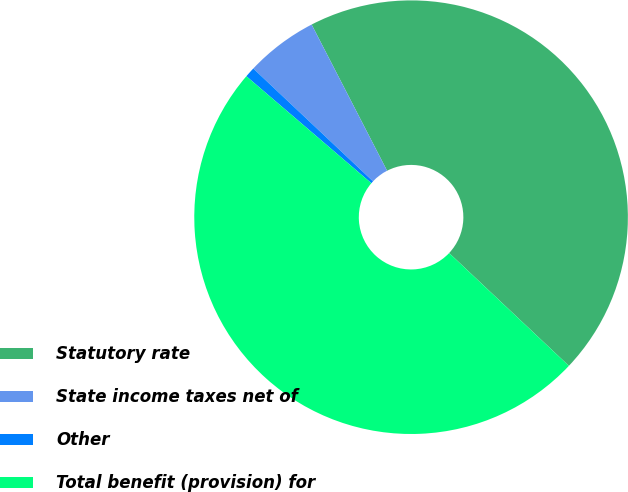<chart> <loc_0><loc_0><loc_500><loc_500><pie_chart><fcel>Statutory rate<fcel>State income taxes net of<fcel>Other<fcel>Total benefit (provision) for<nl><fcel>44.61%<fcel>5.39%<fcel>0.76%<fcel>49.24%<nl></chart> 